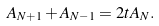Convert formula to latex. <formula><loc_0><loc_0><loc_500><loc_500>A _ { N + 1 } + A _ { N - 1 } = 2 t A _ { N } .</formula> 